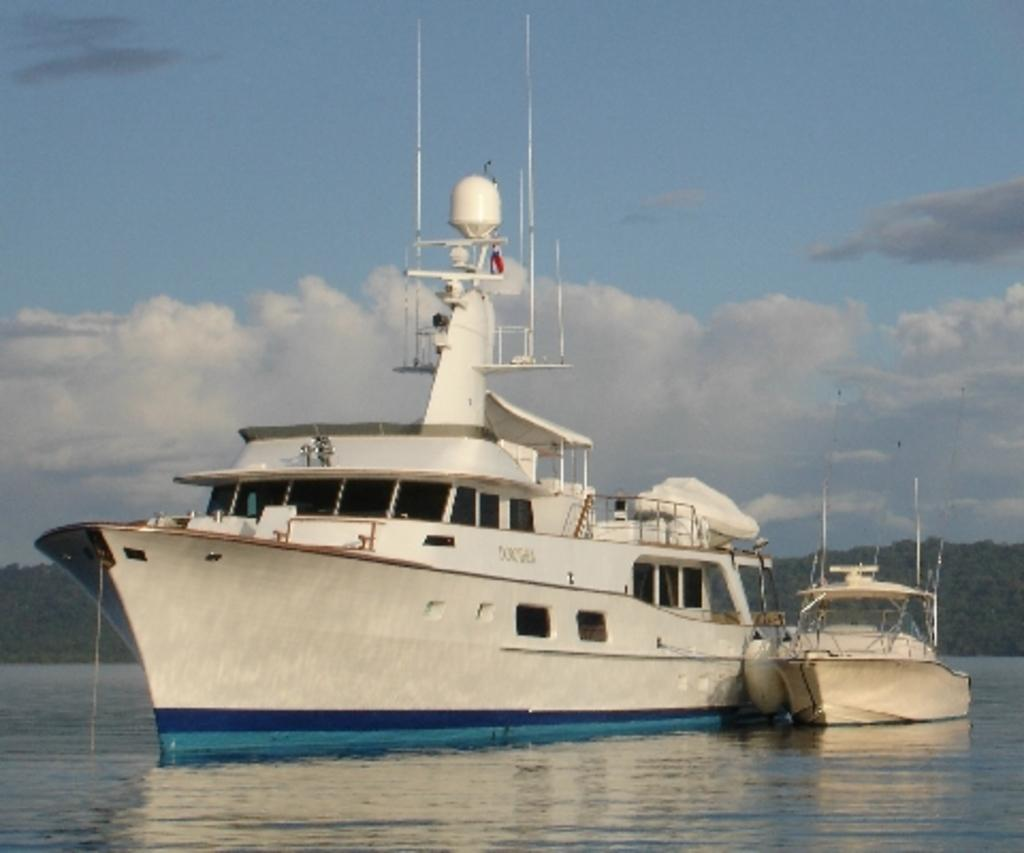What type of watercraft can be seen in the image? There is a ship and a boat in the image. Where are the ship and boat located in the image? Both the ship and boat are on the water in the image. What can be seen in the background of the image? There are trees and the sky visible in the background of the image. What type of drug is being prepared in the stew on the ship? There is no stew or drug present in the image; it features a ship and a boat on the water. 